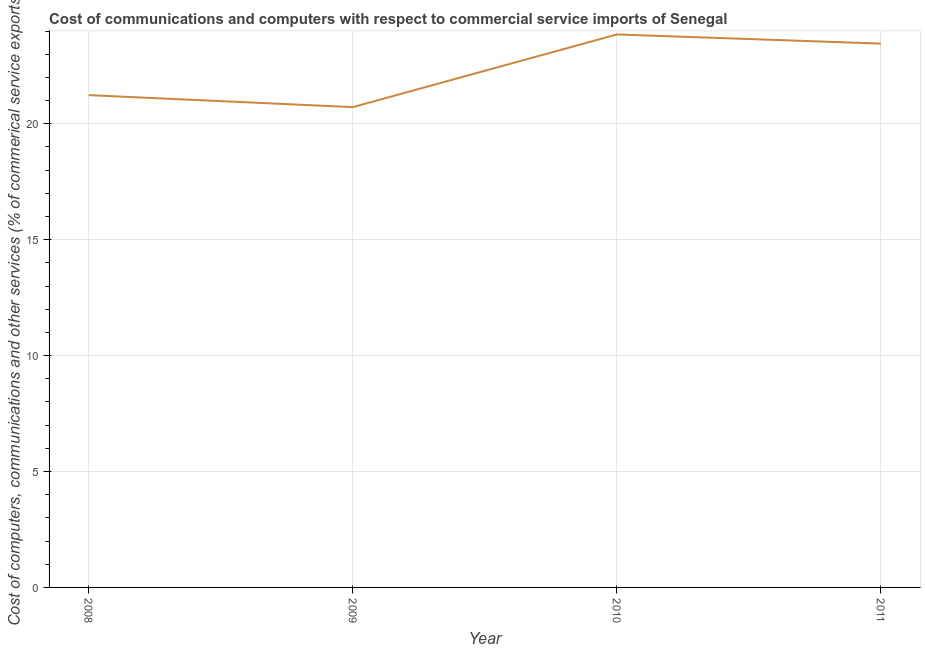What is the cost of communications in 2008?
Offer a terse response. 21.24. Across all years, what is the maximum cost of communications?
Your answer should be very brief. 23.85. Across all years, what is the minimum cost of communications?
Keep it short and to the point. 20.72. In which year was the cost of communications maximum?
Your answer should be very brief. 2010. What is the sum of the  computer and other services?
Provide a short and direct response. 89.27. What is the difference between the  computer and other services in 2008 and 2010?
Your answer should be compact. -2.62. What is the average cost of communications per year?
Make the answer very short. 22.32. What is the median cost of communications?
Ensure brevity in your answer.  22.35. What is the ratio of the cost of communications in 2008 to that in 2011?
Give a very brief answer. 0.91. Is the  computer and other services in 2009 less than that in 2010?
Your answer should be compact. Yes. Is the difference between the cost of communications in 2009 and 2011 greater than the difference between any two years?
Give a very brief answer. No. What is the difference between the highest and the second highest  computer and other services?
Your answer should be very brief. 0.39. Is the sum of the cost of communications in 2010 and 2011 greater than the maximum cost of communications across all years?
Keep it short and to the point. Yes. What is the difference between the highest and the lowest cost of communications?
Your answer should be compact. 3.13. Does the cost of communications monotonically increase over the years?
Offer a terse response. No. How many lines are there?
Ensure brevity in your answer.  1. How many years are there in the graph?
Your answer should be very brief. 4. What is the difference between two consecutive major ticks on the Y-axis?
Your response must be concise. 5. Does the graph contain grids?
Your answer should be very brief. Yes. What is the title of the graph?
Your answer should be very brief. Cost of communications and computers with respect to commercial service imports of Senegal. What is the label or title of the X-axis?
Offer a terse response. Year. What is the label or title of the Y-axis?
Make the answer very short. Cost of computers, communications and other services (% of commerical service exports). What is the Cost of computers, communications and other services (% of commerical service exports) in 2008?
Your response must be concise. 21.24. What is the Cost of computers, communications and other services (% of commerical service exports) in 2009?
Make the answer very short. 20.72. What is the Cost of computers, communications and other services (% of commerical service exports) in 2010?
Give a very brief answer. 23.85. What is the Cost of computers, communications and other services (% of commerical service exports) of 2011?
Your answer should be compact. 23.46. What is the difference between the Cost of computers, communications and other services (% of commerical service exports) in 2008 and 2009?
Offer a terse response. 0.52. What is the difference between the Cost of computers, communications and other services (% of commerical service exports) in 2008 and 2010?
Provide a short and direct response. -2.62. What is the difference between the Cost of computers, communications and other services (% of commerical service exports) in 2008 and 2011?
Offer a very short reply. -2.22. What is the difference between the Cost of computers, communications and other services (% of commerical service exports) in 2009 and 2010?
Offer a very short reply. -3.13. What is the difference between the Cost of computers, communications and other services (% of commerical service exports) in 2009 and 2011?
Your answer should be compact. -2.74. What is the difference between the Cost of computers, communications and other services (% of commerical service exports) in 2010 and 2011?
Provide a short and direct response. 0.39. What is the ratio of the Cost of computers, communications and other services (% of commerical service exports) in 2008 to that in 2009?
Offer a terse response. 1.02. What is the ratio of the Cost of computers, communications and other services (% of commerical service exports) in 2008 to that in 2010?
Your response must be concise. 0.89. What is the ratio of the Cost of computers, communications and other services (% of commerical service exports) in 2008 to that in 2011?
Give a very brief answer. 0.91. What is the ratio of the Cost of computers, communications and other services (% of commerical service exports) in 2009 to that in 2010?
Keep it short and to the point. 0.87. What is the ratio of the Cost of computers, communications and other services (% of commerical service exports) in 2009 to that in 2011?
Give a very brief answer. 0.88. What is the ratio of the Cost of computers, communications and other services (% of commerical service exports) in 2010 to that in 2011?
Your answer should be very brief. 1.02. 